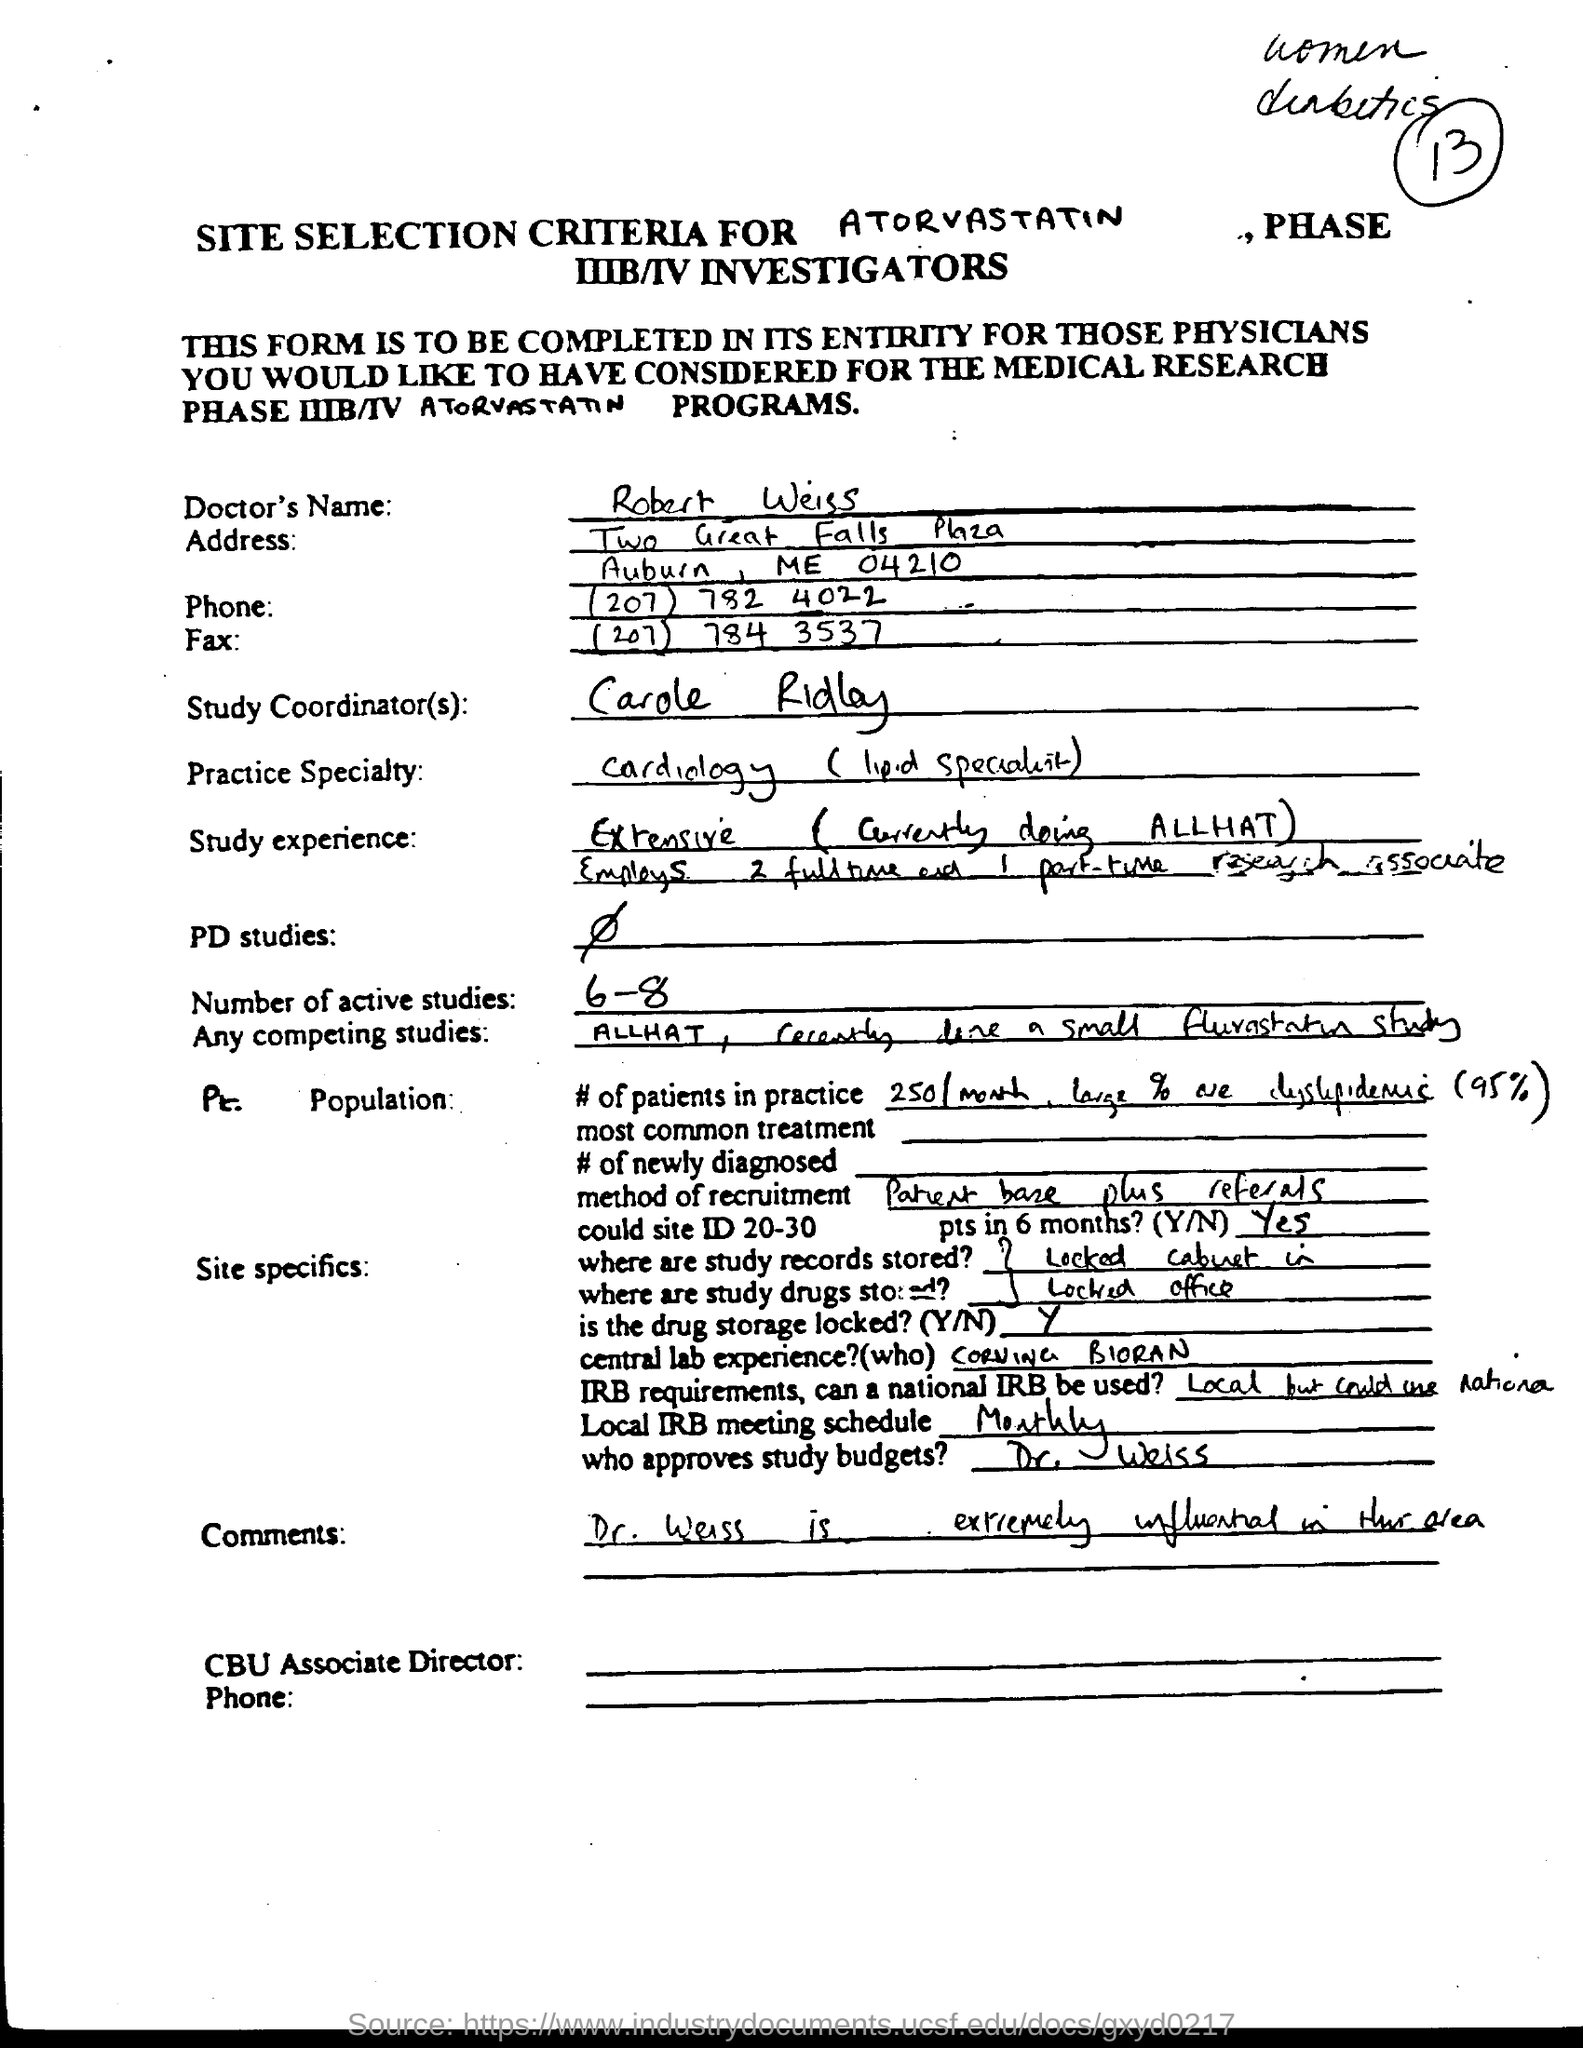Draw attention to some important aspects in this diagram. The phone number is (207) 782 4022. It is known that the name of the doctor is Robert Weiss. The fax number is (207) 784 3537. 